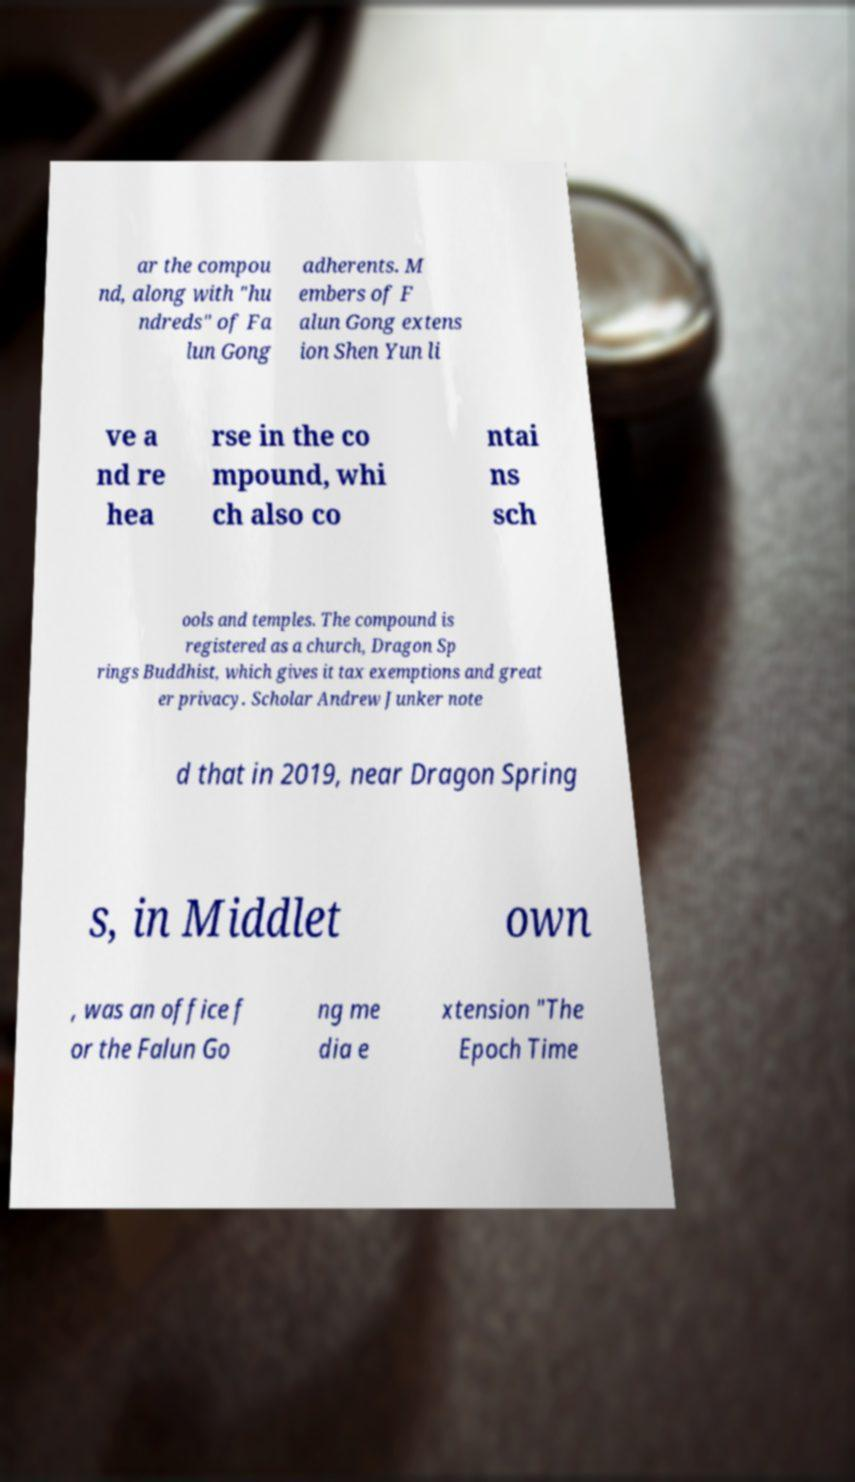There's text embedded in this image that I need extracted. Can you transcribe it verbatim? ar the compou nd, along with "hu ndreds" of Fa lun Gong adherents. M embers of F alun Gong extens ion Shen Yun li ve a nd re hea rse in the co mpound, whi ch also co ntai ns sch ools and temples. The compound is registered as a church, Dragon Sp rings Buddhist, which gives it tax exemptions and great er privacy. Scholar Andrew Junker note d that in 2019, near Dragon Spring s, in Middlet own , was an office f or the Falun Go ng me dia e xtension "The Epoch Time 